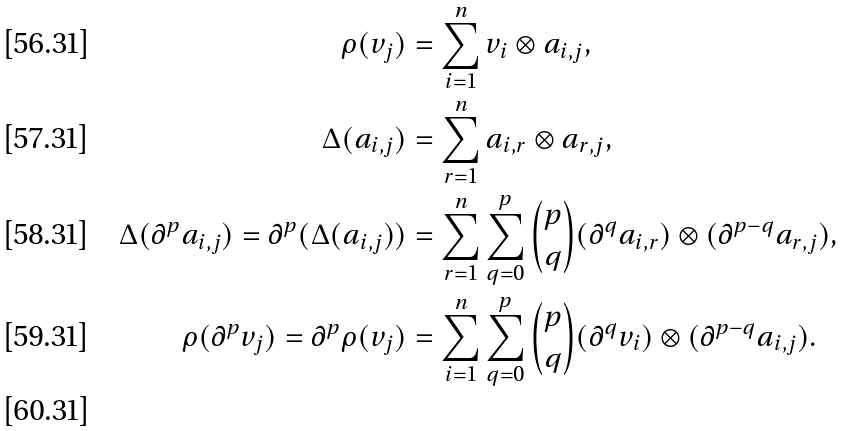<formula> <loc_0><loc_0><loc_500><loc_500>\rho ( v _ { j } ) & = \sum _ { i = 1 } ^ { n } v _ { i } \otimes a _ { i , j } , \\ \Delta ( a _ { i , j } ) & = \sum _ { r = 1 } ^ { n } a _ { i , r } \otimes a _ { r , j } , \\ \Delta ( \partial ^ { p } a _ { i , j } ) = \partial ^ { p } ( \Delta ( a _ { i , j } ) ) & = \sum _ { r = 1 } ^ { n } \sum _ { q = 0 } ^ { p } \binom { p } { q } ( \partial ^ { q } a _ { i , r } ) \otimes ( \partial ^ { p - q } a _ { r , j } ) , \\ \rho ( \partial ^ { p } v _ { j } ) = \partial ^ { p } \rho ( v _ { j } ) & = \sum _ { i = 1 } ^ { n } \sum _ { q = 0 } ^ { p } \binom { p } { q } ( \partial ^ { q } v _ { i } ) \otimes ( \partial ^ { p - q } a _ { i , j } ) . \\</formula> 